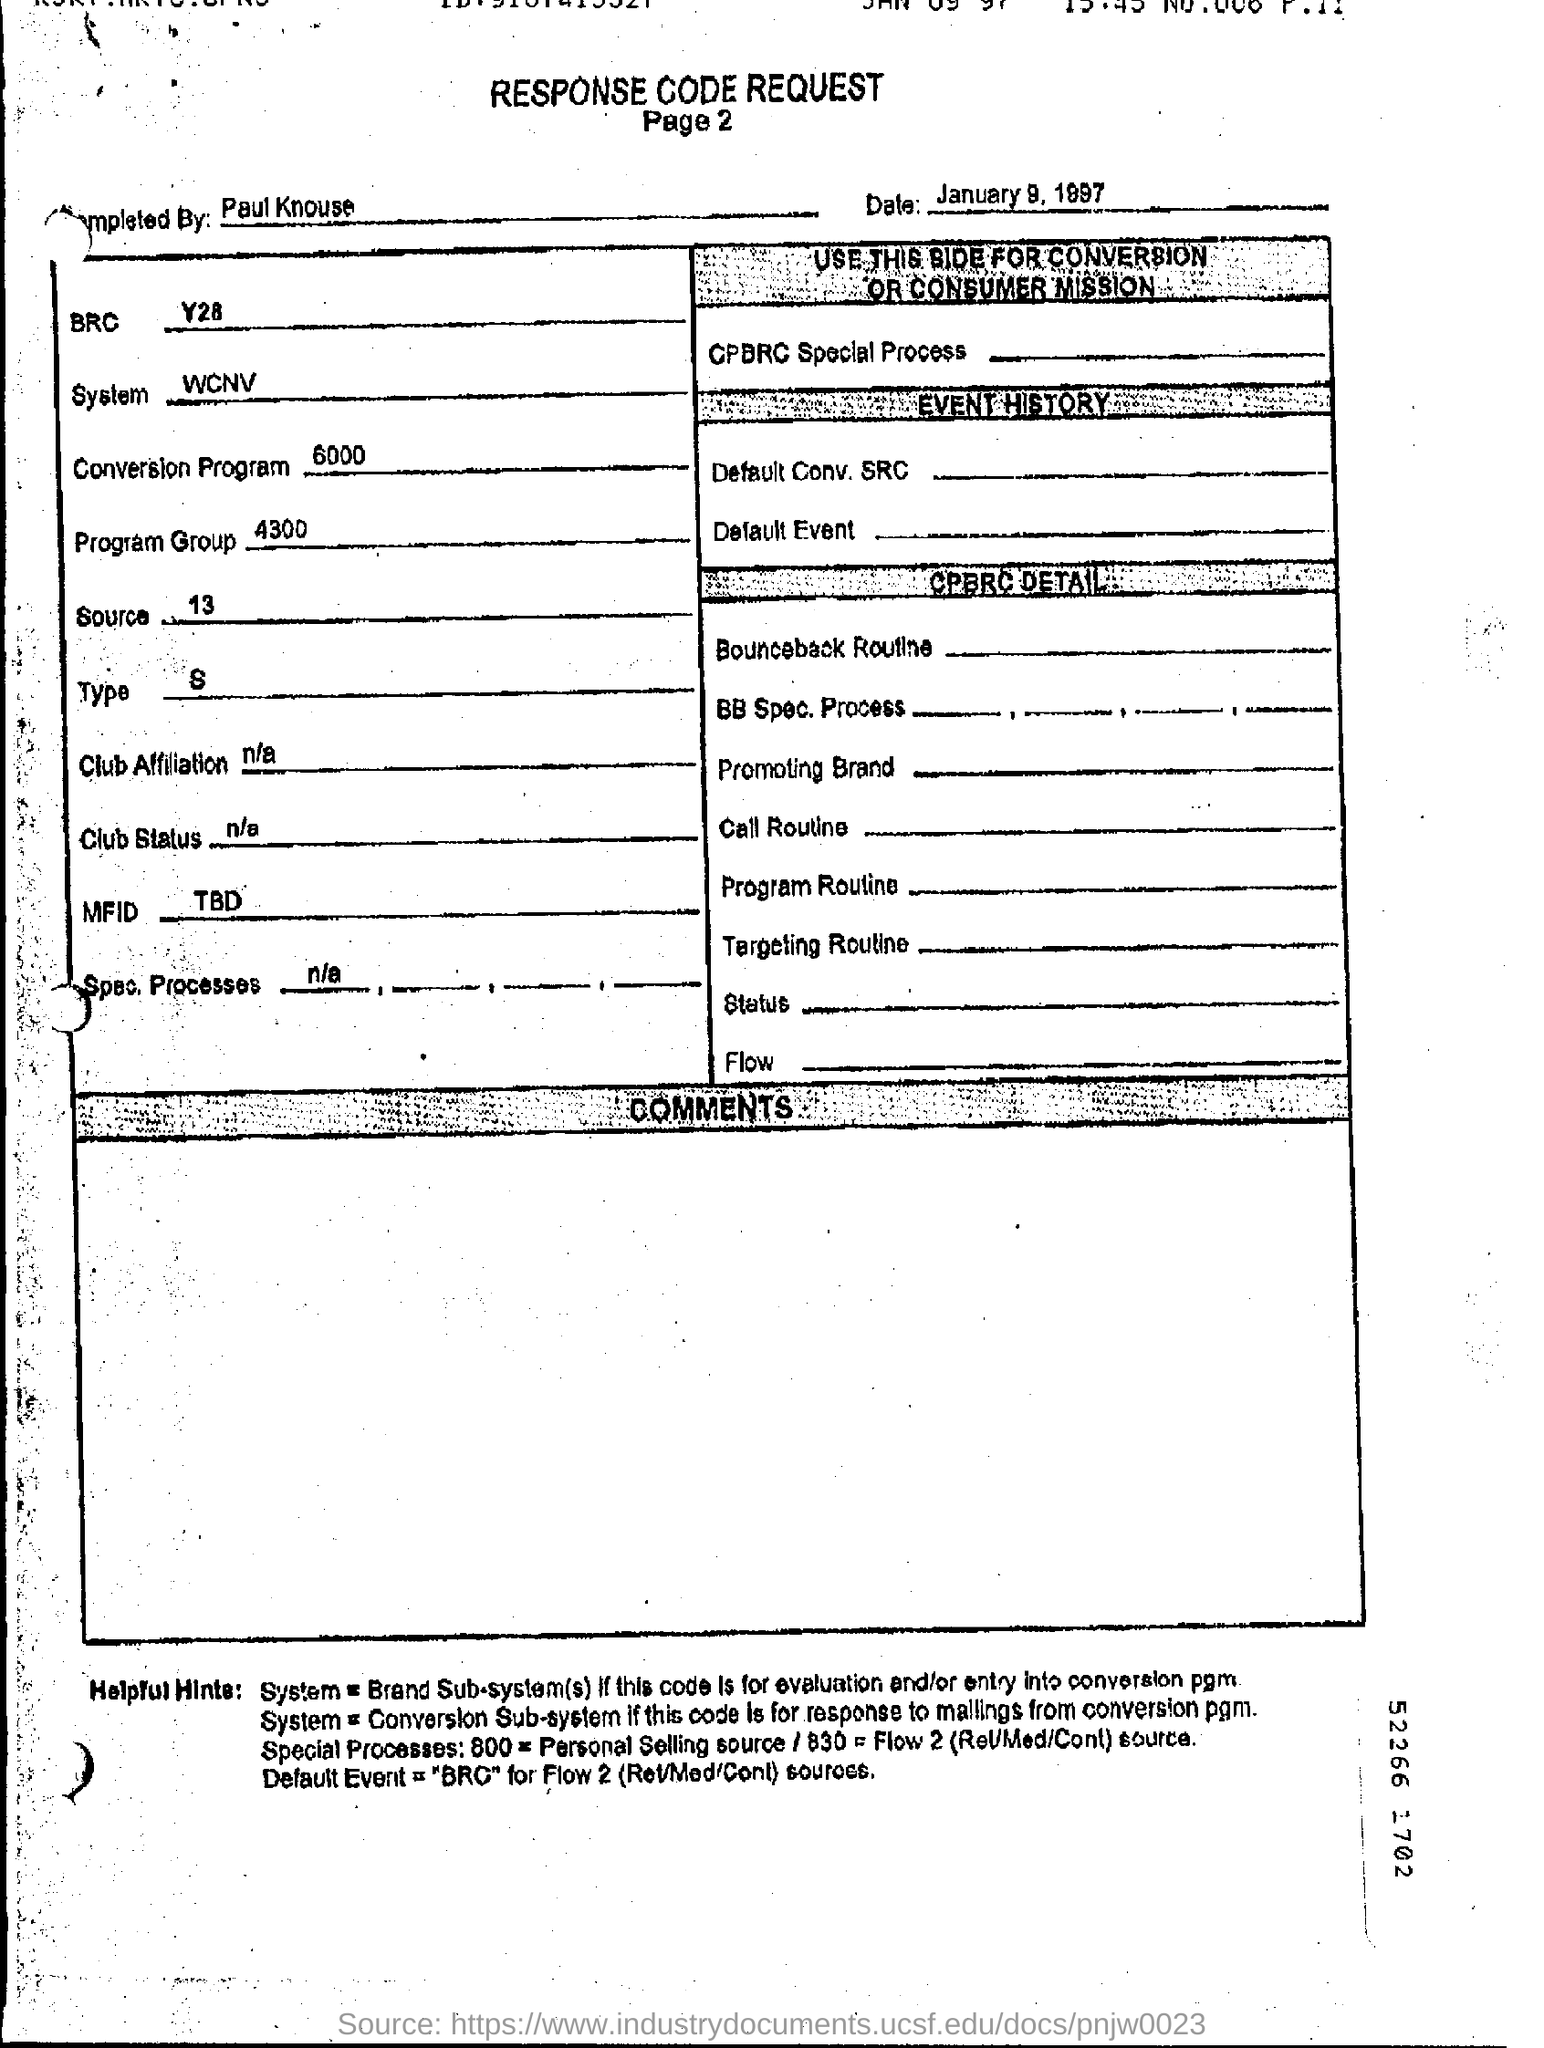Identify some key points in this picture. The conversion program is 6000... The date is January 9, 1997. What is the Source?" is a question that has been asked for centuries, and the answer remains a mystery to this day. The number 13 is often associated with this question and is believed by some to hold the key to unlocking the truth behind its origin. The system is WCNV. What is the title of the document? Response Code Request" can be converted to: "Please provide the title of the document. This request is for a response code. 